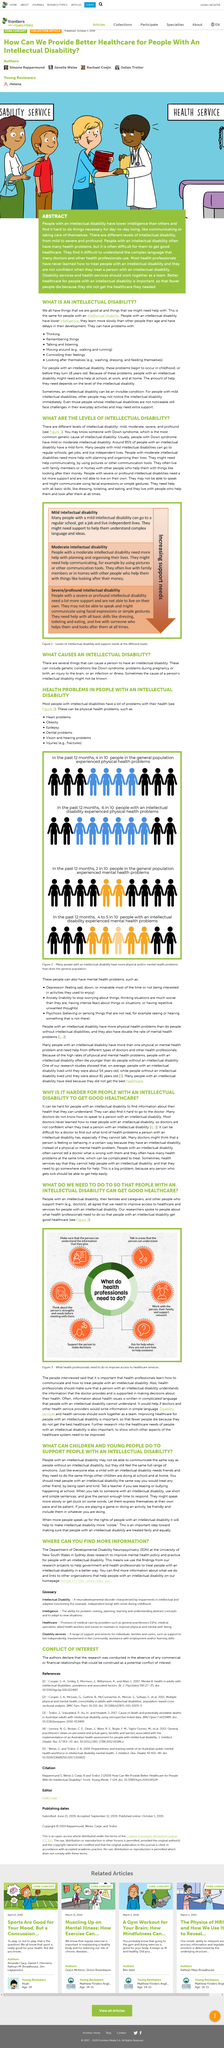Point out several critical features in this image. The title of the article is "What do we need to do to ensure that people with an intellectual disability receive quality healthcare? In the past 12 months, 4 out of 10 people in the general population experienced physical health problems. This equates to approximately 40% of the general population experiencing physical health issues in the past year. On average, people with an intellectual disability are expected to live until they reach approximately 54 years of age. The caption of the picture suggests that healthcare professionals must take necessary actions to enhance access to healthcare services. In the past 12 months, it was determined that 6 out of 10 people with an intellectual disability experienced physical health problems. 